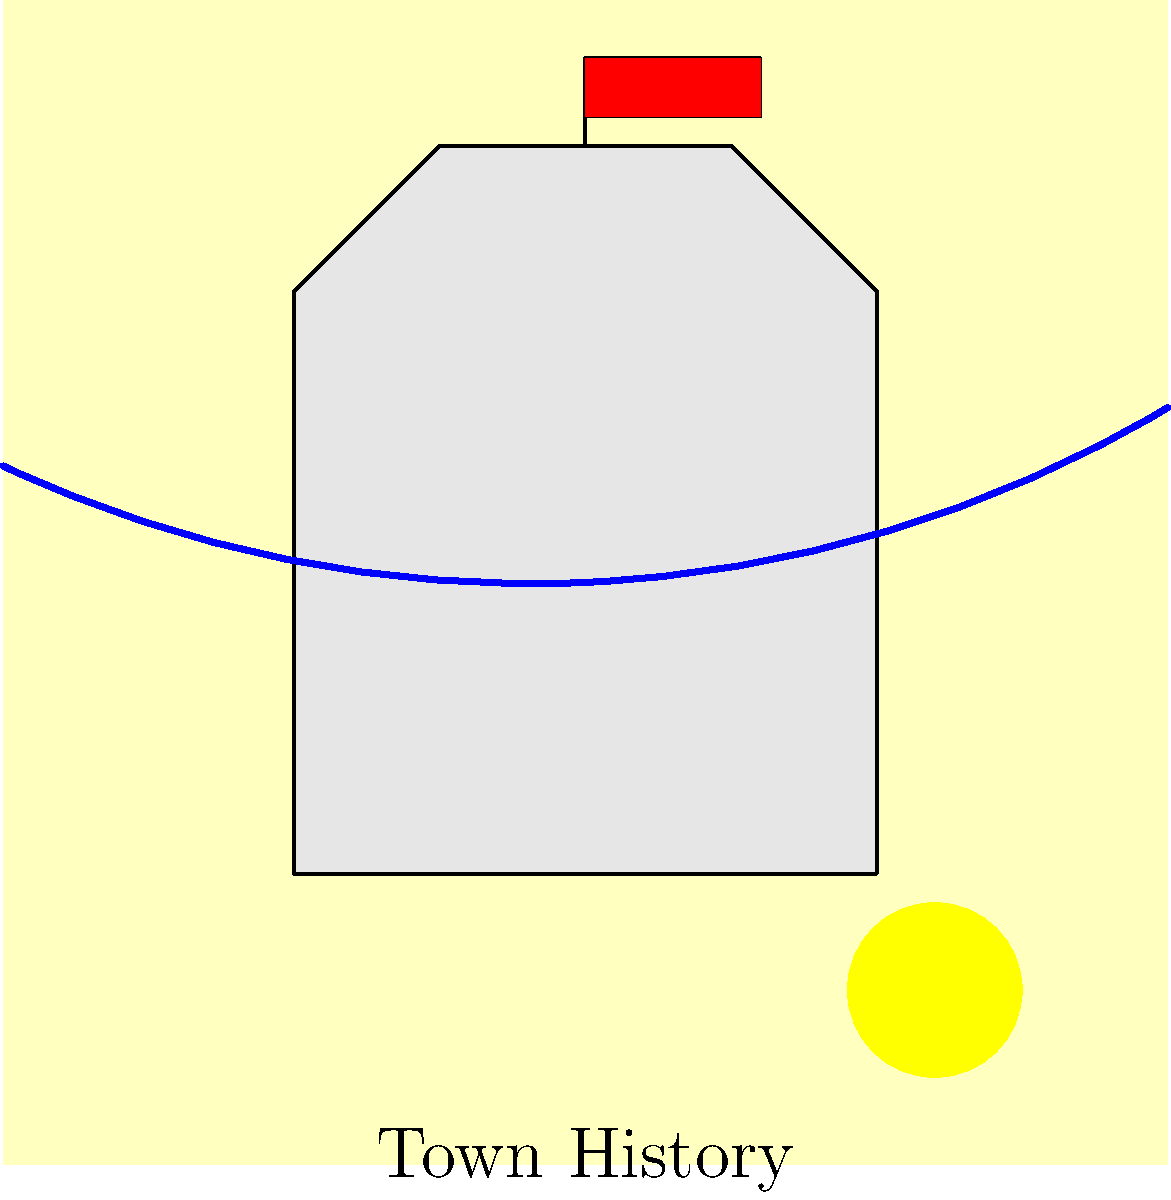In the painting of our town's historic castle, what does the red flag atop the highest tower symbolize, and how does it relate to the town's past glory? To interpret the symbolism in this painting, let's analyze it step-by-step:

1. The castle: Represents the town's strong foundation and rich history. Its prominent position in the center of the painting emphasizes its importance.

2. The red flag: 
   a) Color: Red often symbolizes power, courage, and passion.
   b) Position: Atop the highest tower, it signifies dominance and pride.

3. Historical context: In our town's history, red was the color of the ruling aristocratic family.

4. The sun: Positioned in the top right corner, it suggests a new dawn or a bright future, balancing the historical elements.

5. The river: Flowing across the bottom of the painting, it symbolizes the continuity of life and the passage of time.

Connecting these elements:
The red flag atop the castle symbolizes the enduring legacy of the aristocratic rule that once governed our town. Its prominent position suggests that even though times have changed (as indicated by the sun), the town still takes pride in its noble heritage. The river at the bottom reinforces the idea that while time flows on, the essence of our history remains.

This interpretation aligns with the perspective of a former aristocrat who fondly remembers the town's glory days, seeing the flag as a reminder of the past influence and prestige of the ruling class.
Answer: The red flag symbolizes the enduring legacy and pride in the town's aristocratic past. 